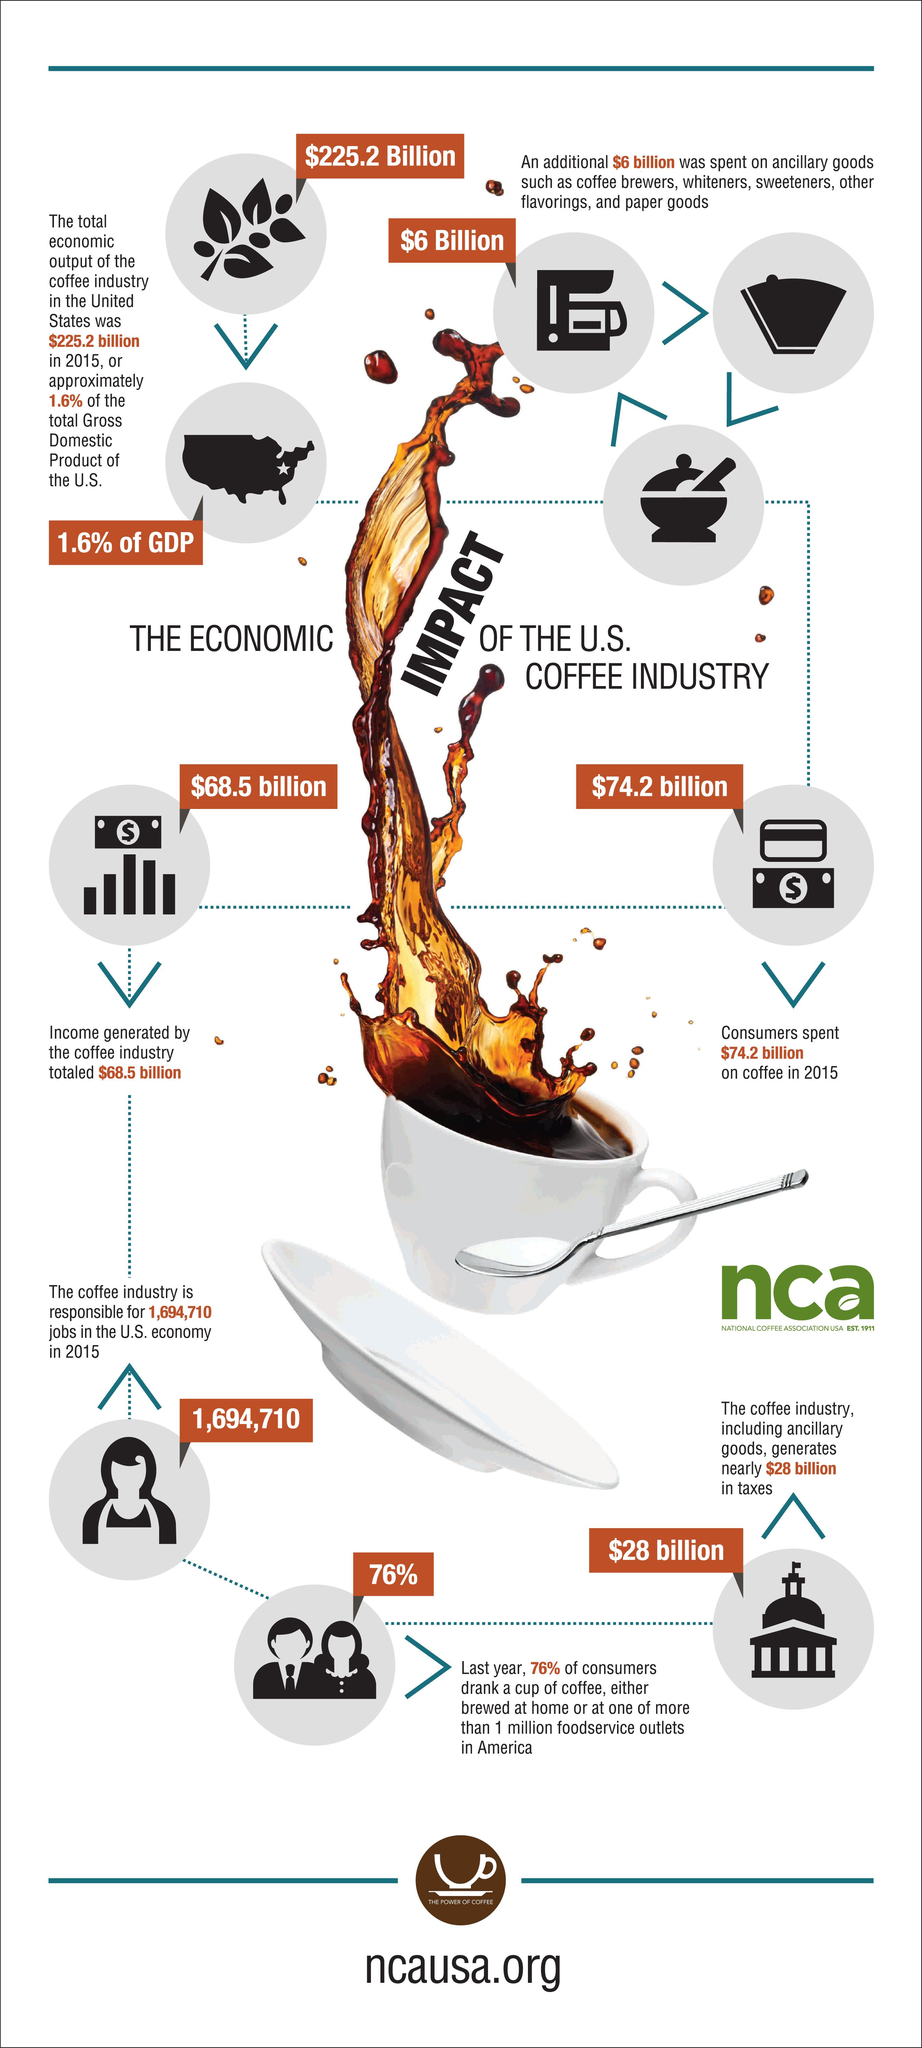Highlight a few significant elements in this photo. In 2015, consumers in the U.S. spent a total of $74.2 billion on coffee. In 2015, the coffee industry in the United States created an estimated 1,694,710 jobs. In 2015, the coffee industry in the United States generated an income of approximately $68.5 billion. According to recent data, the coffee industry contributed 1.6% of the total Gross Domestic Product (GDP) of the United States. 